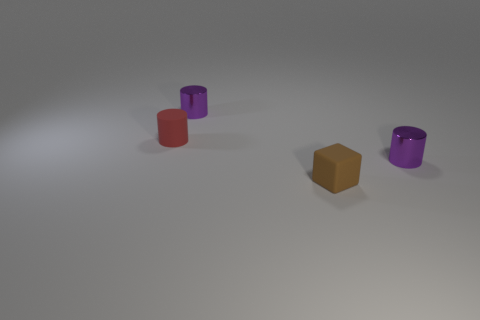Is the number of tiny brown cubes that are to the left of the red matte thing less than the number of small brown things?
Ensure brevity in your answer.  Yes. The object behind the rubber object to the left of the purple cylinder that is on the left side of the small brown rubber block is what shape?
Give a very brief answer. Cylinder. There is a purple cylinder in front of the red matte cylinder; how big is it?
Provide a short and direct response. Small. There is another rubber object that is the same size as the brown object; what shape is it?
Your response must be concise. Cylinder. How many objects are either red matte cylinders or small objects that are in front of the red cylinder?
Ensure brevity in your answer.  3. There is a red object left of the cylinder on the right side of the tiny cube; what number of tiny purple cylinders are behind it?
Ensure brevity in your answer.  1. There is a block that is the same material as the small red thing; what color is it?
Your answer should be compact. Brown. What number of objects are either small red cylinders or small gray rubber spheres?
Provide a succinct answer. 1. There is a object that is in front of the small purple metallic cylinder right of the tiny metal cylinder on the left side of the brown matte object; what is it made of?
Offer a terse response. Rubber. There is a tiny object that is right of the rubber block; what material is it?
Offer a terse response. Metal. 